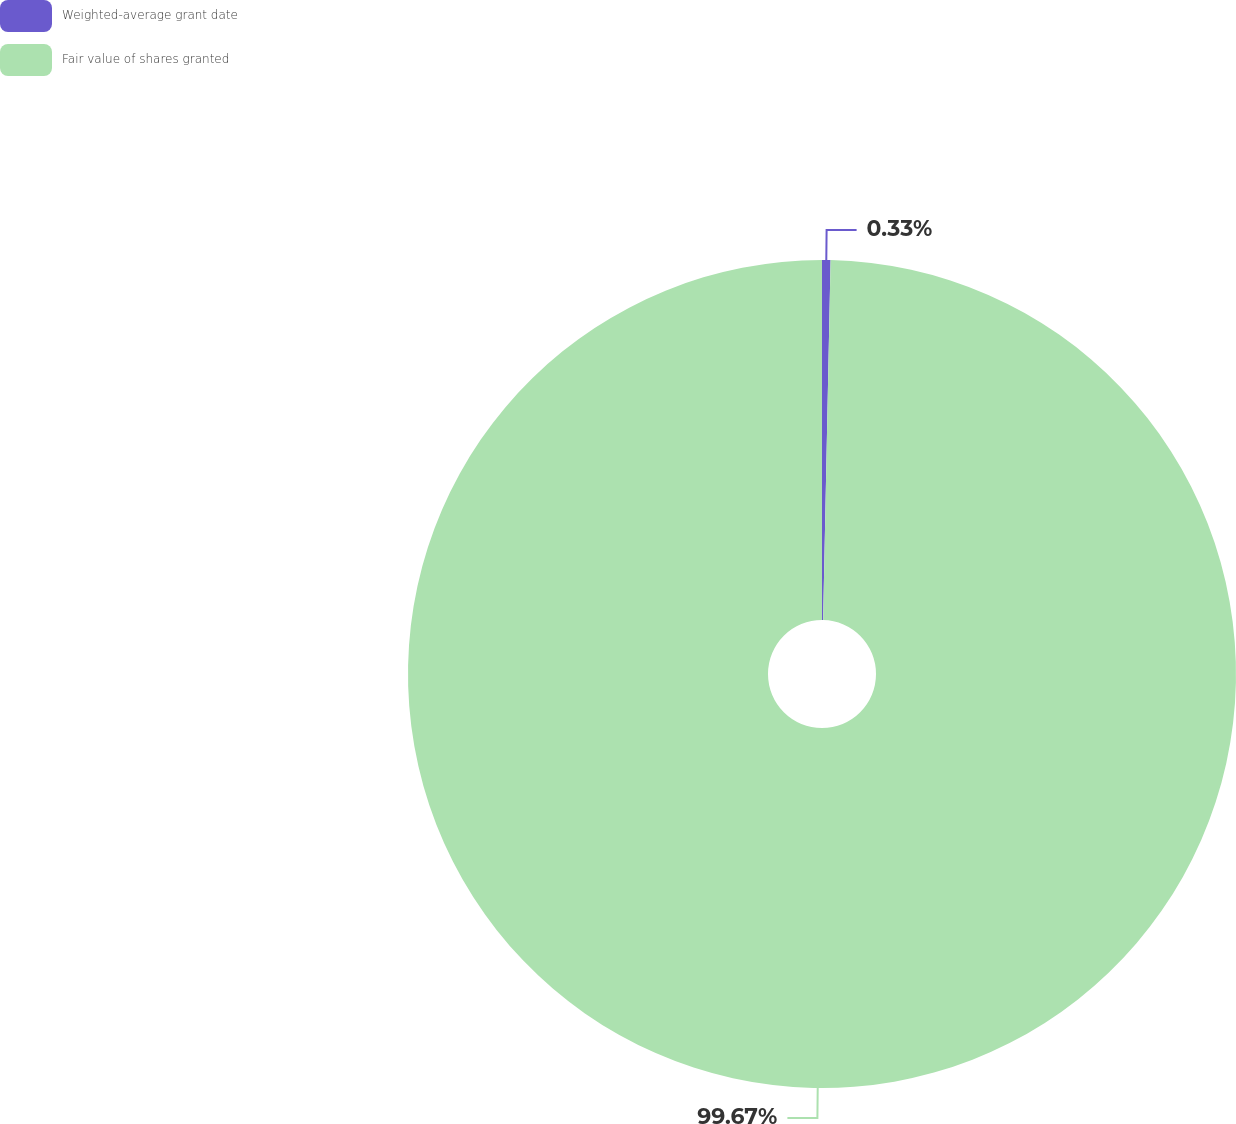Convert chart to OTSL. <chart><loc_0><loc_0><loc_500><loc_500><pie_chart><fcel>Weighted-average grant date<fcel>Fair value of shares granted<nl><fcel>0.33%<fcel>99.67%<nl></chart> 